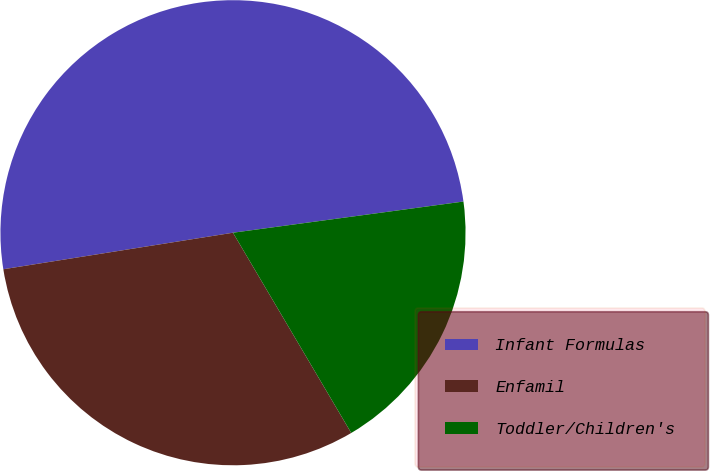Convert chart to OTSL. <chart><loc_0><loc_0><loc_500><loc_500><pie_chart><fcel>Infant Formulas<fcel>Enfamil<fcel>Toddler/Children's<nl><fcel>50.37%<fcel>30.98%<fcel>18.65%<nl></chart> 